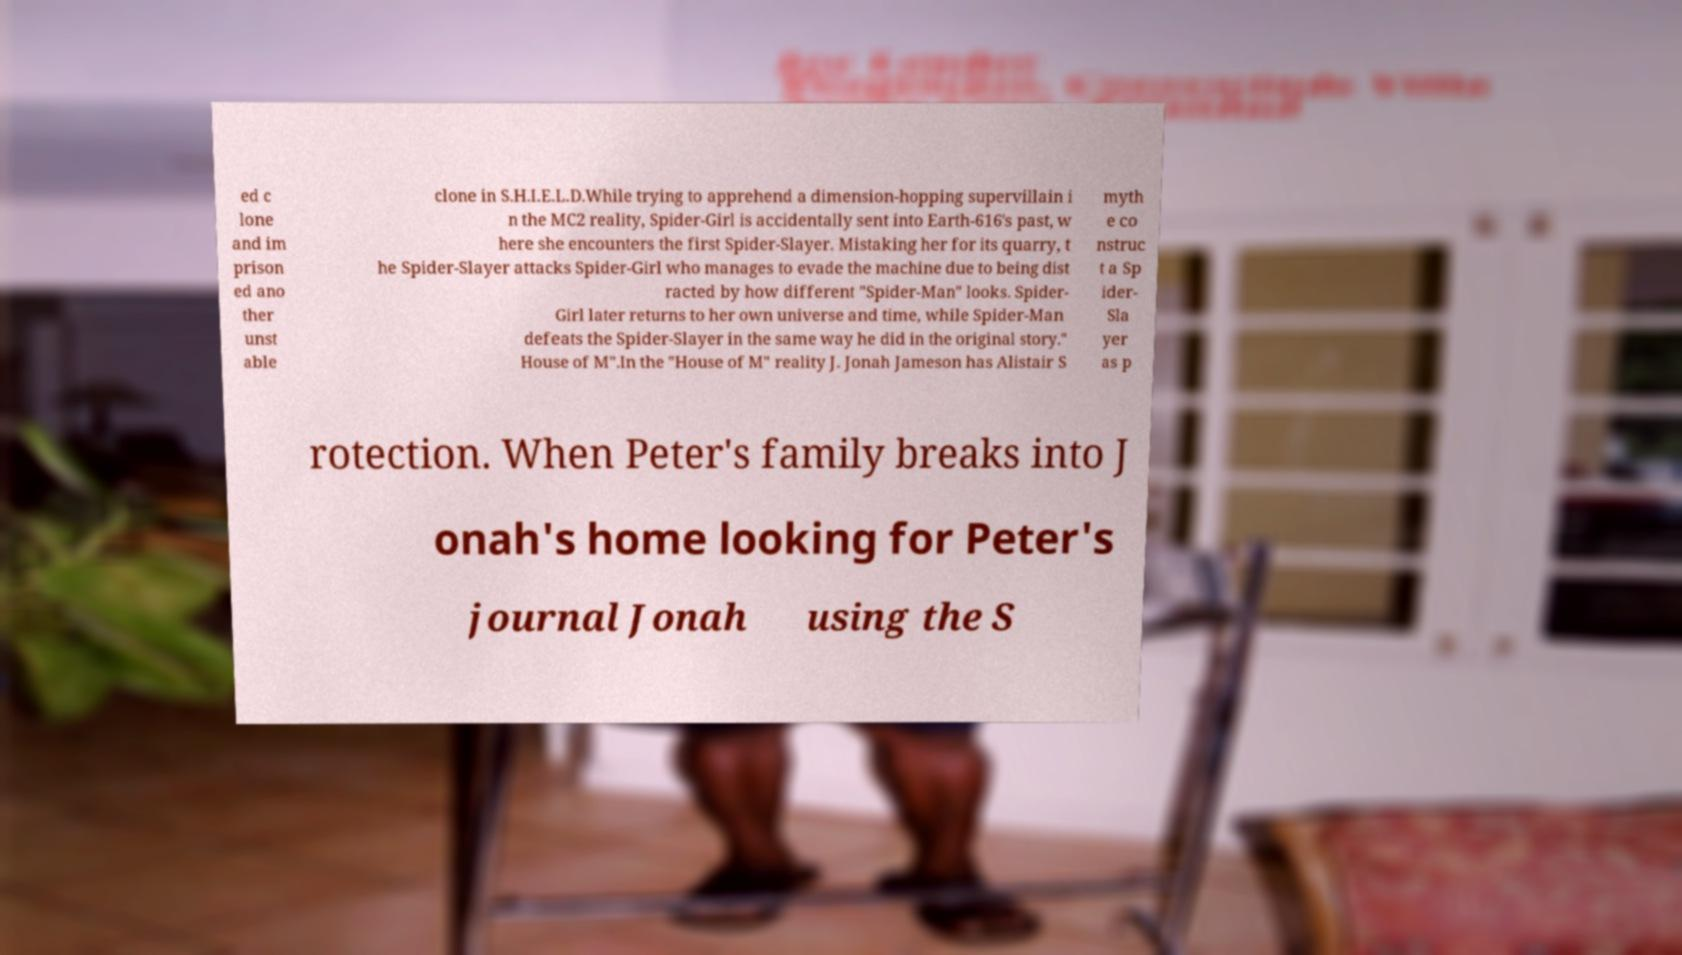What messages or text are displayed in this image? I need them in a readable, typed format. ed c lone and im prison ed ano ther unst able clone in S.H.I.E.L.D.While trying to apprehend a dimension-hopping supervillain i n the MC2 reality, Spider-Girl is accidentally sent into Earth-616's past, w here she encounters the first Spider-Slayer. Mistaking her for its quarry, t he Spider-Slayer attacks Spider-Girl who manages to evade the machine due to being dist racted by how different "Spider-Man" looks. Spider- Girl later returns to her own universe and time, while Spider-Man defeats the Spider-Slayer in the same way he did in the original story." House of M".In the "House of M" reality J. Jonah Jameson has Alistair S myth e co nstruc t a Sp ider- Sla yer as p rotection. When Peter's family breaks into J onah's home looking for Peter's journal Jonah using the S 